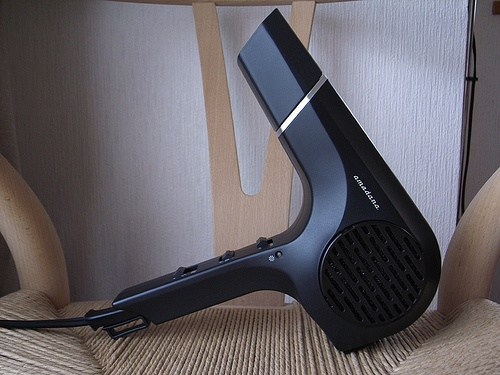Describe the objects in this image and their specific colors. I can see chair in black, gray, and darkgray tones and hair drier in black, gray, and darkblue tones in this image. 